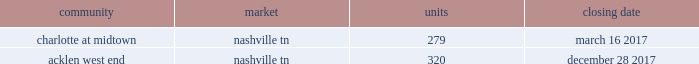2022 secondary market same store communities are generally communities in markets with populations of more than 1 million but less than 1% ( 1 % ) of the total public multifamily reit units or markets with populations of less than 1 million that we have owned and have been stabilized for at least a full 12 months .
2022 non-same store communities and other includes recent acquisitions , communities in development or lease-up , communities that have been identified for disposition , and communities that have undergone a significant casualty loss .
Also included in non-same store communities are non-multifamily activities .
On the first day of each calendar year , we determine the composition of our same store operating segments for that year as well as adjust the previous year , which allows us to evaluate full period-over-period operating comparisons .
An apartment community in development or lease-up is added to the same store portfolio on the first day of the calendar year after it has been owned and stabilized for at least a full 12 months .
Communities are considered stabilized after achieving 90% ( 90 % ) occupancy for 90 days .
Communities that have been identified for disposition are excluded from the same store portfolio .
All properties acquired from post properties in the merger remained in the non-same store and other operating segment during 2017 , as the properties were recent acquisitions and had not been owned and stabilized for at least 12 months as of january 1 , 2017 .
For additional information regarding our operating segments , see note 14 to the consolidated financial statements included elsewhere in this annual report on form 10-k .
Acquisitions one of our growth strategies is to acquire apartment communities that are located in various large or secondary markets primarily throughout the southeast and southwest regions of the united states .
Acquisitions , along with dispositions , help us achieve and maintain our desired product mix , geographic diversification and asset allocation .
Portfolio growth allows for maximizing the efficiency of the existing management and overhead structure .
We have extensive experience in the acquisition of multifamily communities .
We will continue to evaluate opportunities that arise , and we will utilize this strategy to increase our number of apartment communities in strong and growing markets .
We acquired the following apartment communities during the year ended december 31 , 2017: .
Dispositions we sell apartment communities and other assets that no longer meet our long-term strategy or when market conditions are favorable , and we redeploy the proceeds from those sales to acquire , develop and redevelop additional apartment communities and rebalance our portfolio across or within geographic regions .
Dispositions also allow us to realize a portion of the value created through our investments and provide additional liquidity .
We are then able to redeploy the net proceeds from our dispositions in lieu of raising additional capital .
In deciding to sell an apartment community , we consider current market conditions and generally solicit competing bids from unrelated parties for these individual assets , considering the sales price and other key terms of each proposal .
We also consider portfolio dispositions when such a structure is useful to maximize proceeds and efficiency of execution .
During the year ended december 31 , 2017 , we disposed of five multifamily properties totaling 1760 units and four land parcels totaling approximately 23 acres .
Development as another part of our growth strategy , we invest in a limited number of development projects .
Development activities may be conducted through wholly-owned affiliated companies or through joint ventures with unaffiliated parties .
Fixed price construction contracts are signed with unrelated parties to minimize construction risk .
We typically manage the leasing portion of the project as units become available for lease .
We may also engage in limited expansion development opportunities on existing communities in which we typically serve as the developer .
While we seek opportunistic new development investments offering attractive long-term investment returns , we intend to maintain a total development commitment that we consider modest in relation to our total balance sheet and investment portfolio .
During the year ended december 31 , 2017 , we incurred $ 170.1 million in development costs and completed 7 development projects. .
What the number of units purchased in december 31 , 2017? 
Computations: (279 + 320)
Answer: 599.0. 